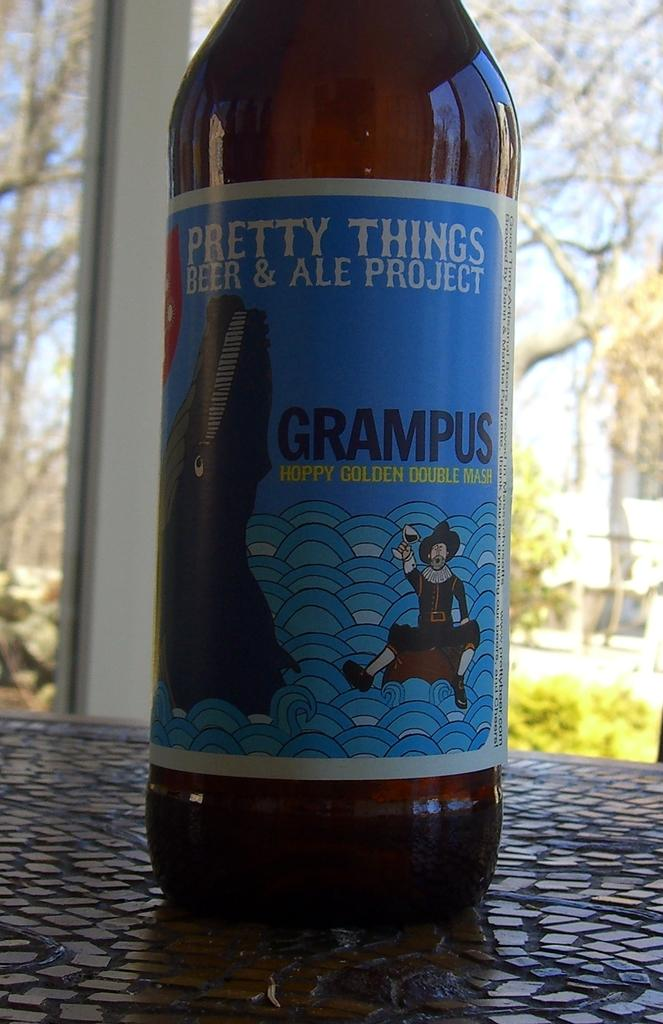<image>
Relay a brief, clear account of the picture shown. A bottle of "Pretty things beer and ale project" 